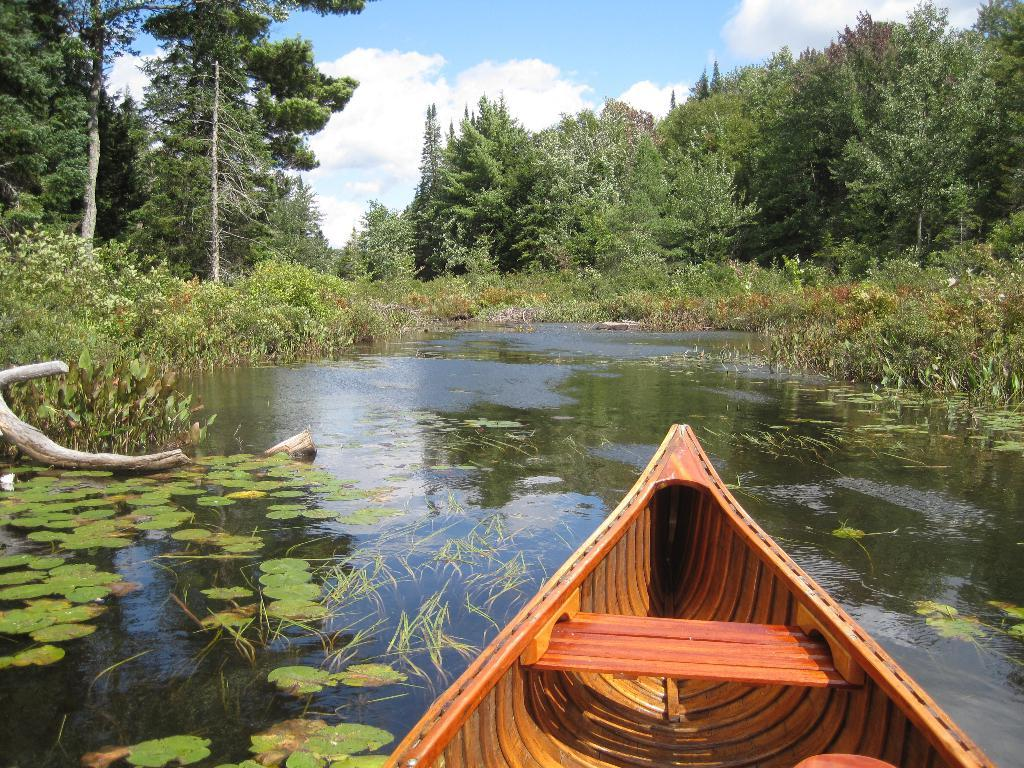What is the main subject of the image? There is a boat in the image. What type of vegetation can be seen in the image? Leaves are present in the image. What material are the sticks visible in the image made of? The wooden sticks are visible in the image. What is the primary element in which the boat is situated? There is water in the image. What can be seen in the background of the image? Trees and the sky are visible in the background of the image. What is the condition of the sky in the image? Clouds are present in the sky. How many ducks are sitting on the middle wooden stick in the image? There are no ducks present in the image, so it is not possible to answer that question. 